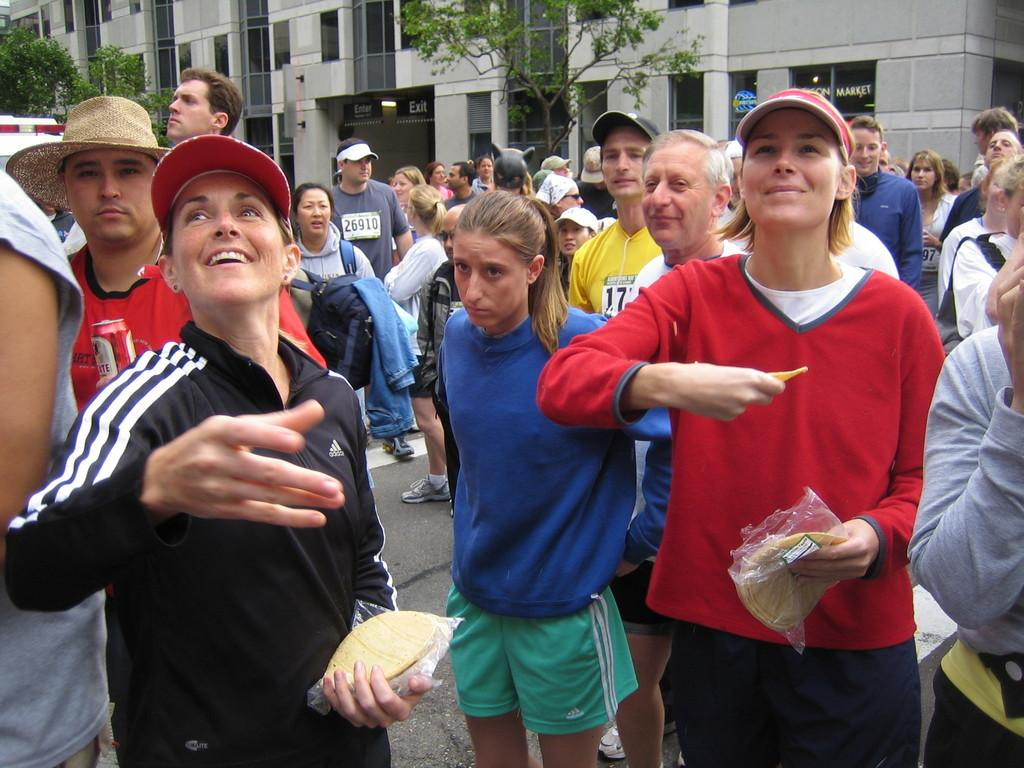How many people are in the group in the image? There is a group of people in the image, but the exact number is not specified. What is the facial expression of some people in the group? Some people in the group are smiling. What type of headwear can be seen in the image? Caps are visible in the image. What items might be used for carrying belongings? Bags are present in the image. What type of food items can be seen in the image? Food items are present in the image, but the specific types are not mentioned. What type of vegetation is visible in the image? Trees are visible in the image. What type of signage is present in the image? Name boards are present in the image. What type of structures are visible in the image? Buildings are visible in the image. What type of transportation is present in the image? A vehicle is present in the image. What other objects can be seen in the image? There are other objects in the image, but their specific types are not mentioned. Where is the stage located in the image? There is no stage present in the image. What type of wish can be granted by the people in the image? There is no mention of wishes or granting wishes in the image. 